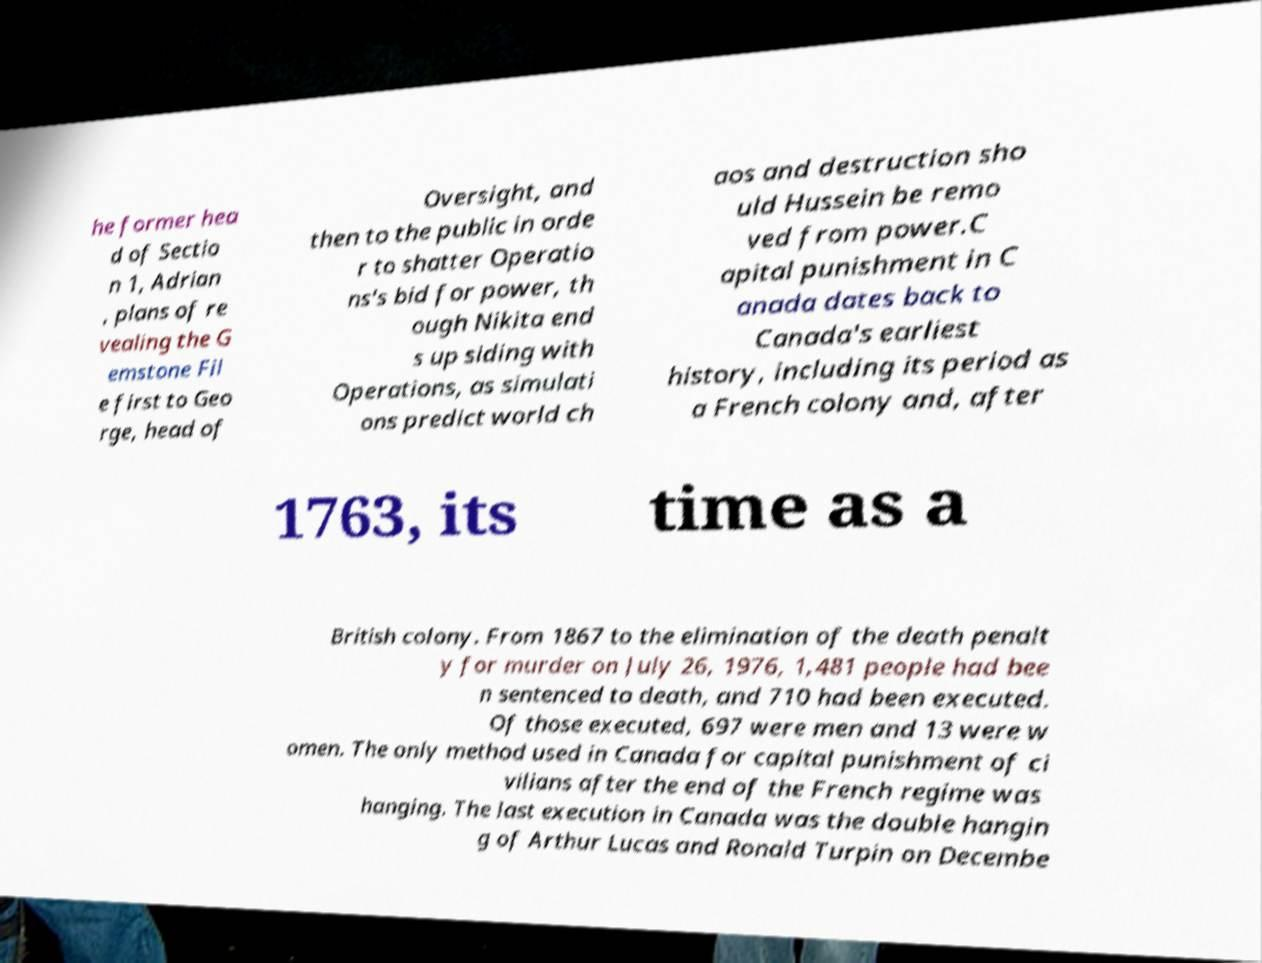Can you accurately transcribe the text from the provided image for me? he former hea d of Sectio n 1, Adrian , plans of re vealing the G emstone Fil e first to Geo rge, head of Oversight, and then to the public in orde r to shatter Operatio ns's bid for power, th ough Nikita end s up siding with Operations, as simulati ons predict world ch aos and destruction sho uld Hussein be remo ved from power.C apital punishment in C anada dates back to Canada's earliest history, including its period as a French colony and, after 1763, its time as a British colony. From 1867 to the elimination of the death penalt y for murder on July 26, 1976, 1,481 people had bee n sentenced to death, and 710 had been executed. Of those executed, 697 were men and 13 were w omen. The only method used in Canada for capital punishment of ci vilians after the end of the French regime was hanging. The last execution in Canada was the double hangin g of Arthur Lucas and Ronald Turpin on Decembe 